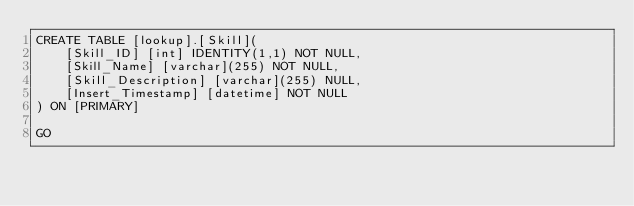<code> <loc_0><loc_0><loc_500><loc_500><_SQL_>CREATE TABLE [lookup].[Skill](
	[Skill_ID] [int] IDENTITY(1,1) NOT NULL,
	[Skill_Name] [varchar](255) NOT NULL,
	[Skill_Description] [varchar](255) NULL,
	[Insert_Timestamp] [datetime] NOT NULL
) ON [PRIMARY]

GO


</code> 